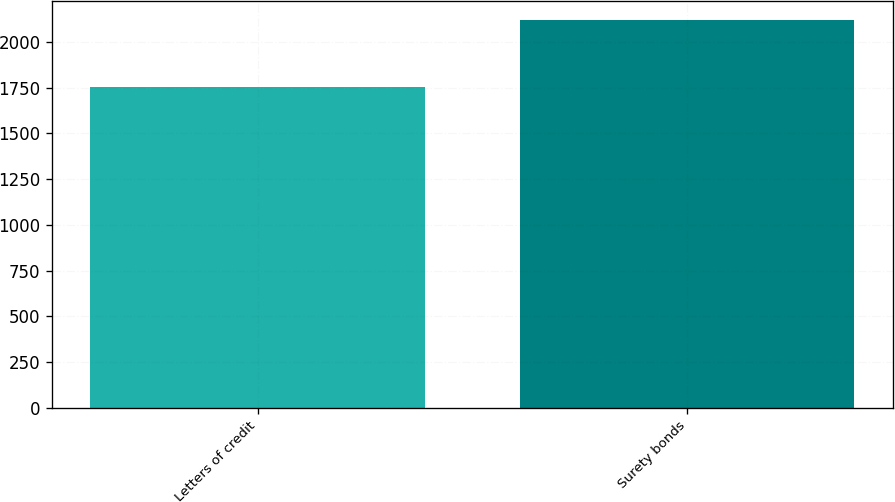<chart> <loc_0><loc_0><loc_500><loc_500><bar_chart><fcel>Letters of credit<fcel>Surety bonds<nl><fcel>1753.1<fcel>2119.2<nl></chart> 